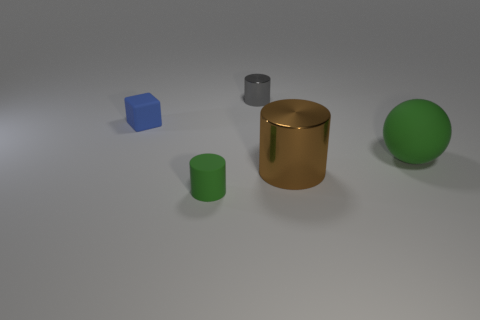What number of small rubber objects are the same color as the matte ball?
Keep it short and to the point. 1. What is the size of the brown metal thing?
Provide a short and direct response. Large. There is a big matte object; is its shape the same as the green object that is left of the large metal cylinder?
Provide a short and direct response. No. What is the color of the tiny cylinder that is the same material as the blue block?
Provide a succinct answer. Green. There is a cylinder that is behind the large matte object; what is its size?
Provide a succinct answer. Small. Are there fewer things in front of the brown thing than brown shiny cylinders?
Provide a short and direct response. No. Is the tiny shiny object the same color as the small matte cylinder?
Your answer should be compact. No. Are there any other things that have the same shape as the tiny green object?
Provide a short and direct response. Yes. Is the number of small blue matte blocks less than the number of large yellow cubes?
Your answer should be very brief. No. There is a large thing that is right of the shiny cylinder in front of the green matte sphere; what color is it?
Keep it short and to the point. Green. 